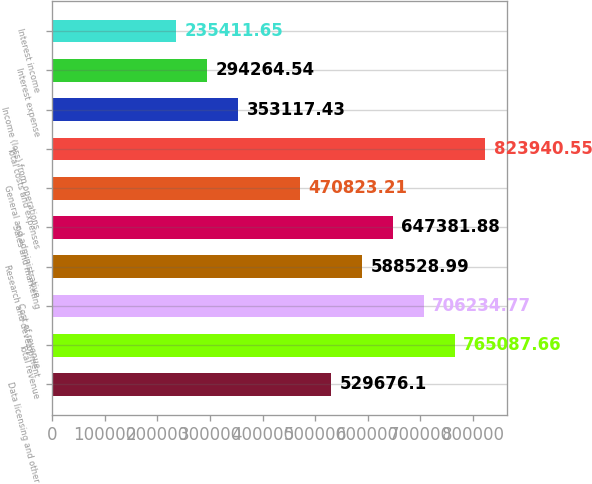<chart> <loc_0><loc_0><loc_500><loc_500><bar_chart><fcel>Data licensing and other<fcel>Total revenue<fcel>Cost of revenue<fcel>Research and development<fcel>Sales and marketing<fcel>General and administrative<fcel>Total costs and expenses<fcel>Income (loss) from operations<fcel>Interest expense<fcel>Interest income<nl><fcel>529676<fcel>765088<fcel>706235<fcel>588529<fcel>647382<fcel>470823<fcel>823941<fcel>353117<fcel>294265<fcel>235412<nl></chart> 